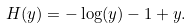<formula> <loc_0><loc_0><loc_500><loc_500>H ( y ) = - \log ( y ) - 1 + y .</formula> 